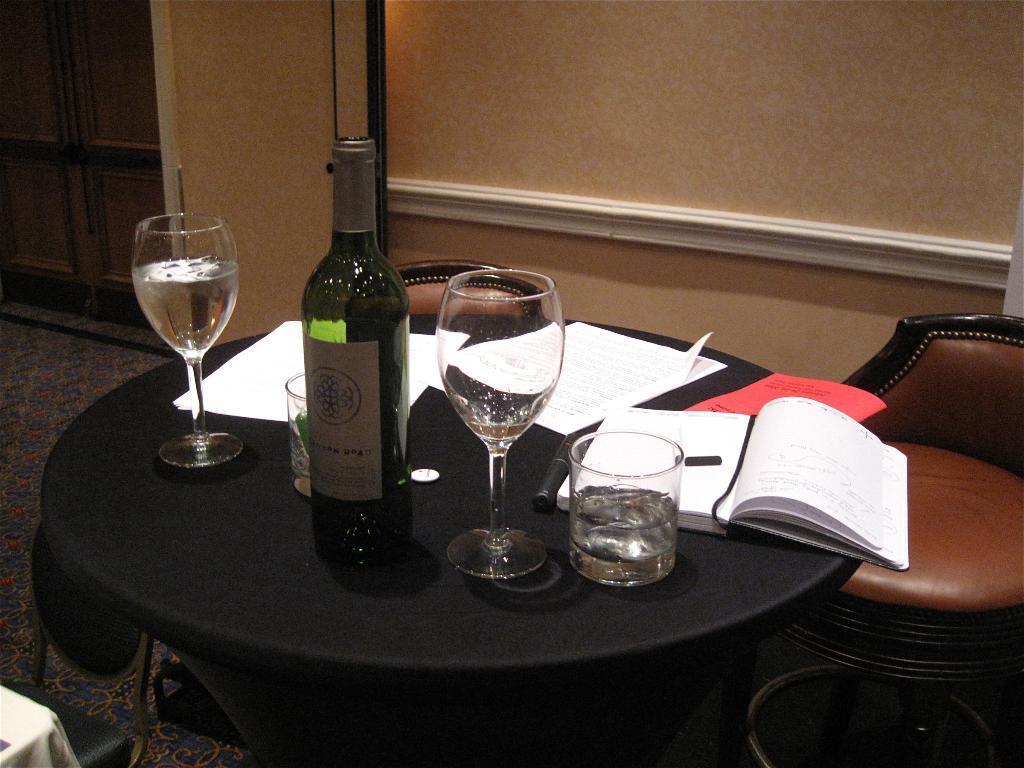How would you summarize this image in a sentence or two? As we can see in the image, there is a table and a chair. On table there are glasses, bottle, books and behind the table there is a wall. 